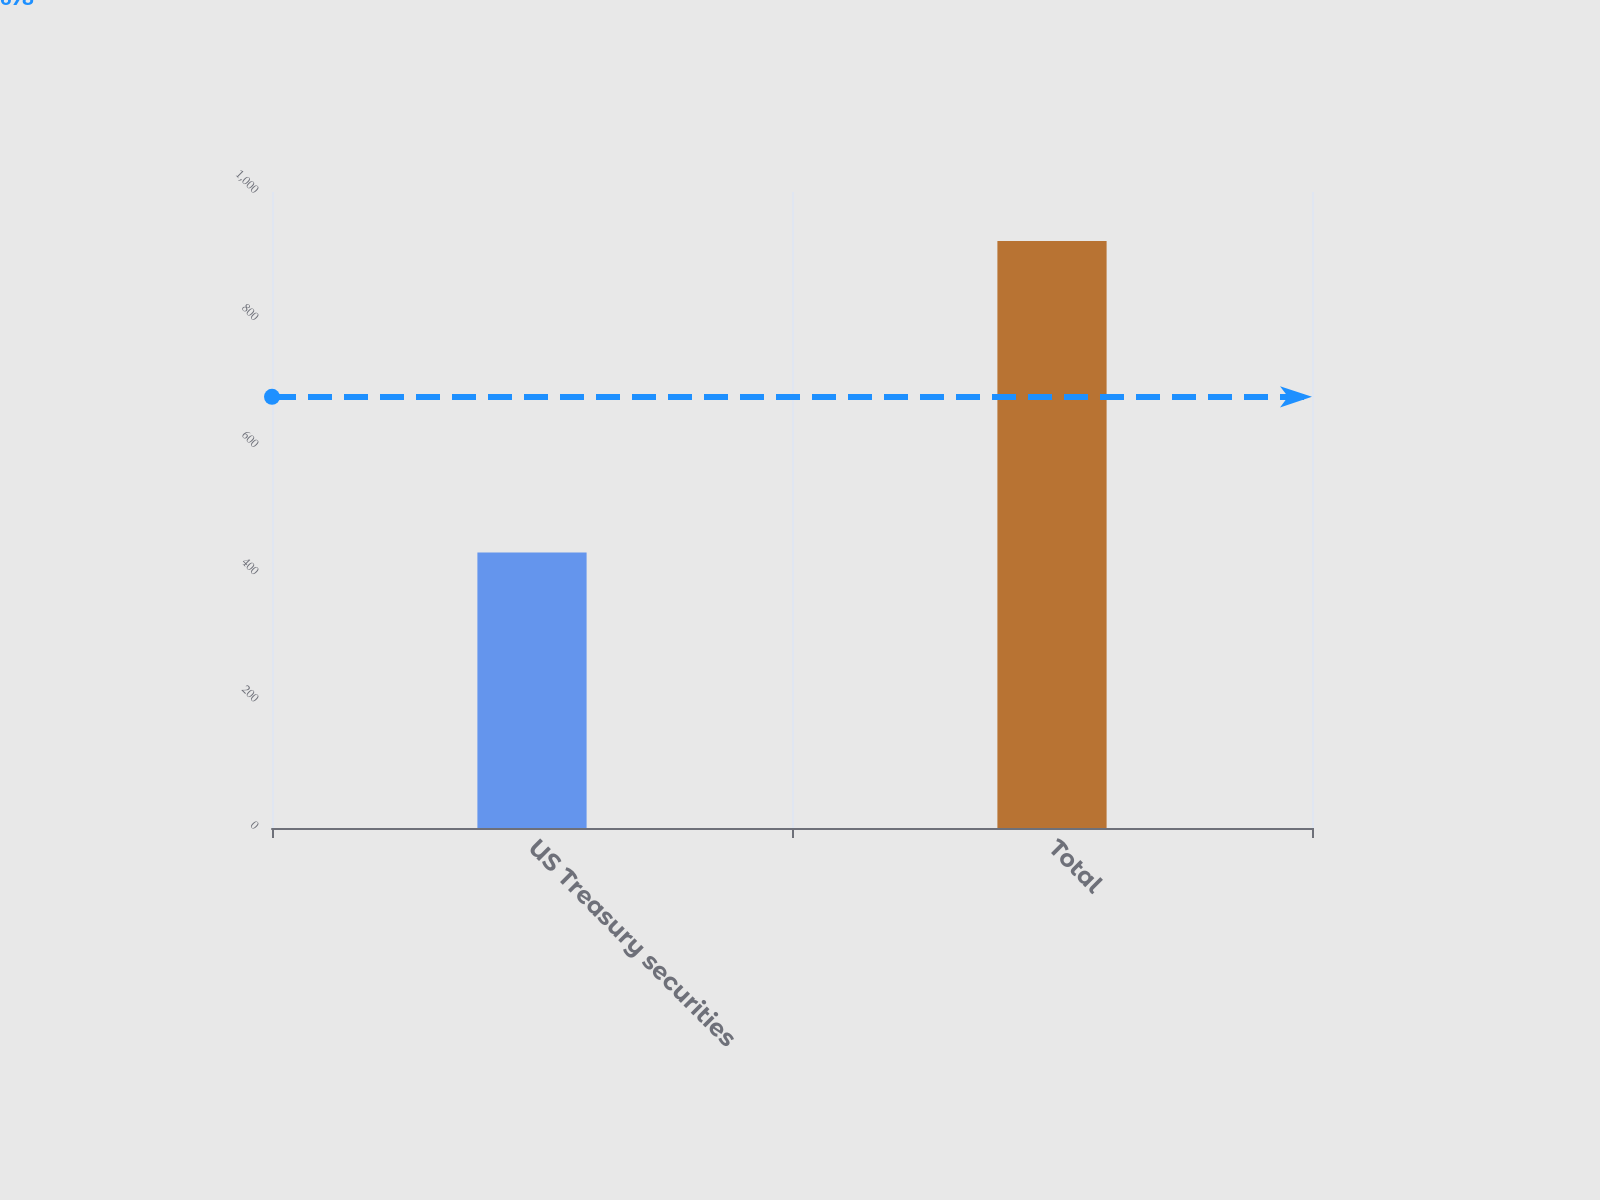Convert chart to OTSL. <chart><loc_0><loc_0><loc_500><loc_500><bar_chart><fcel>US Treasury securities<fcel>Total<nl><fcel>433<fcel>923<nl></chart> 